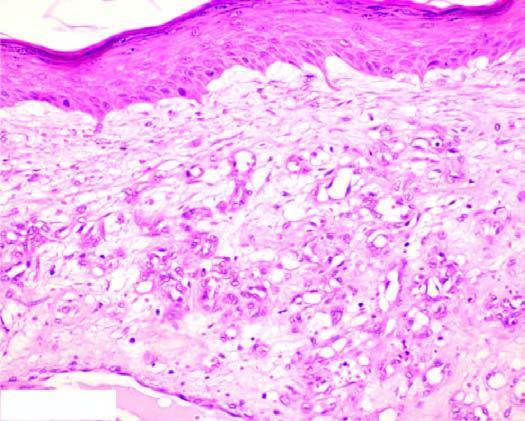re there capillaries lined by plump endothelial cells and containing blood?
Answer the question using a single word or phrase. Yes 